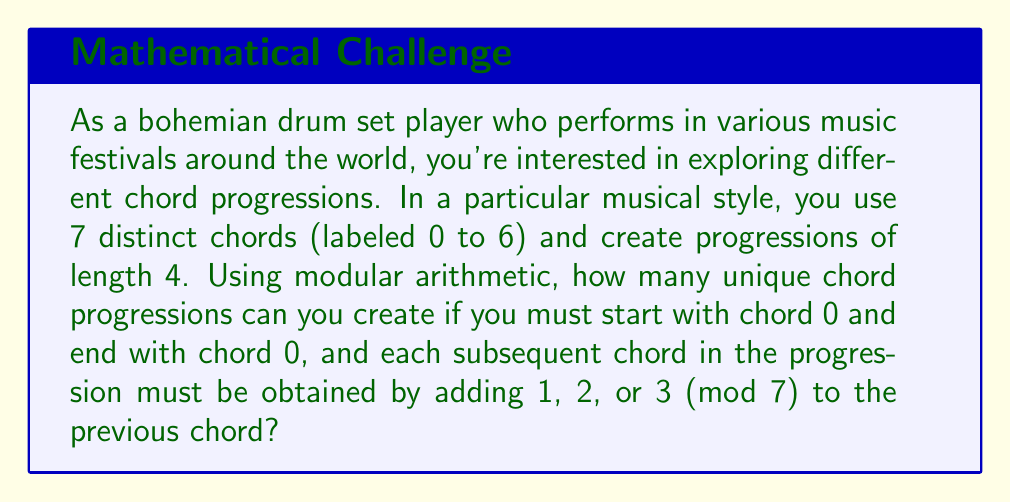Show me your answer to this math problem. Let's approach this step-by-step:

1) We start with chord 0 and end with chord 0, so we need to determine the middle two chords.

2) For each step, we can add 1, 2, or 3 (mod 7) to the previous chord. This means we have 3 choices for each step.

3) Let's consider the possible progressions:

   Step 1: 0 → {1, 2, 3}
   Step 2: {1, 2, 3} → {2, 3, 4, 5, 6, 0}
   Step 3: {2, 3, 4, 5, 6, 0} → 0

4) To end up at 0 after the third step, the chord before the last must be one of {4, 5, 6}.

5) Now, let's count the number of ways to reach each of these:

   To reach 4: 
   0 → 1 → 4
   0 → 2 → 4
   0 → 3 → 4

   To reach 5:
   0 → 2 → 5
   0 → 3 → 5

   To reach 6:
   0 → 3 → 6

6) Counting these up, we have:
   3 ways to reach 4
   2 ways to reach 5
   1 way to reach 6

7) Therefore, the total number of unique chord progressions is:

   $$ 3 + 2 + 1 = 6 $$

This can also be calculated using the multiplication principle:

$$ 3 \text{ (choices for first step)} \times 2 \text{ (choices for second step)} = 6 $$
Answer: There are 6 unique chord progressions possible under the given constraints. 